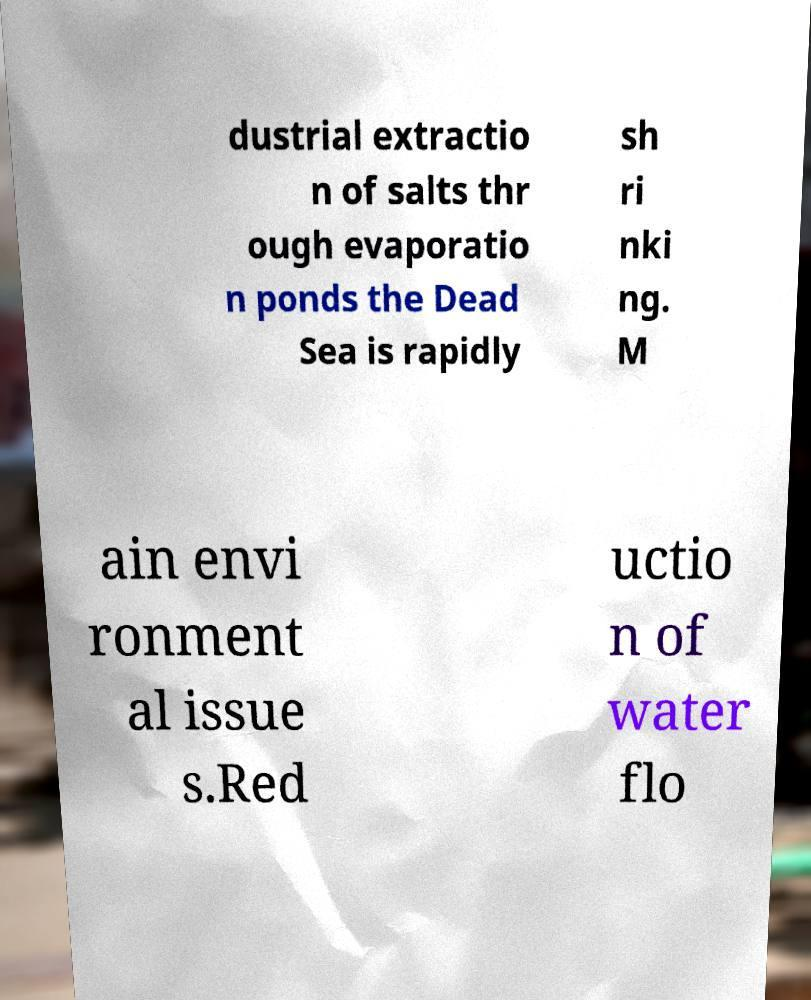Can you accurately transcribe the text from the provided image for me? dustrial extractio n of salts thr ough evaporatio n ponds the Dead Sea is rapidly sh ri nki ng. M ain envi ronment al issue s.Red uctio n of water flo 